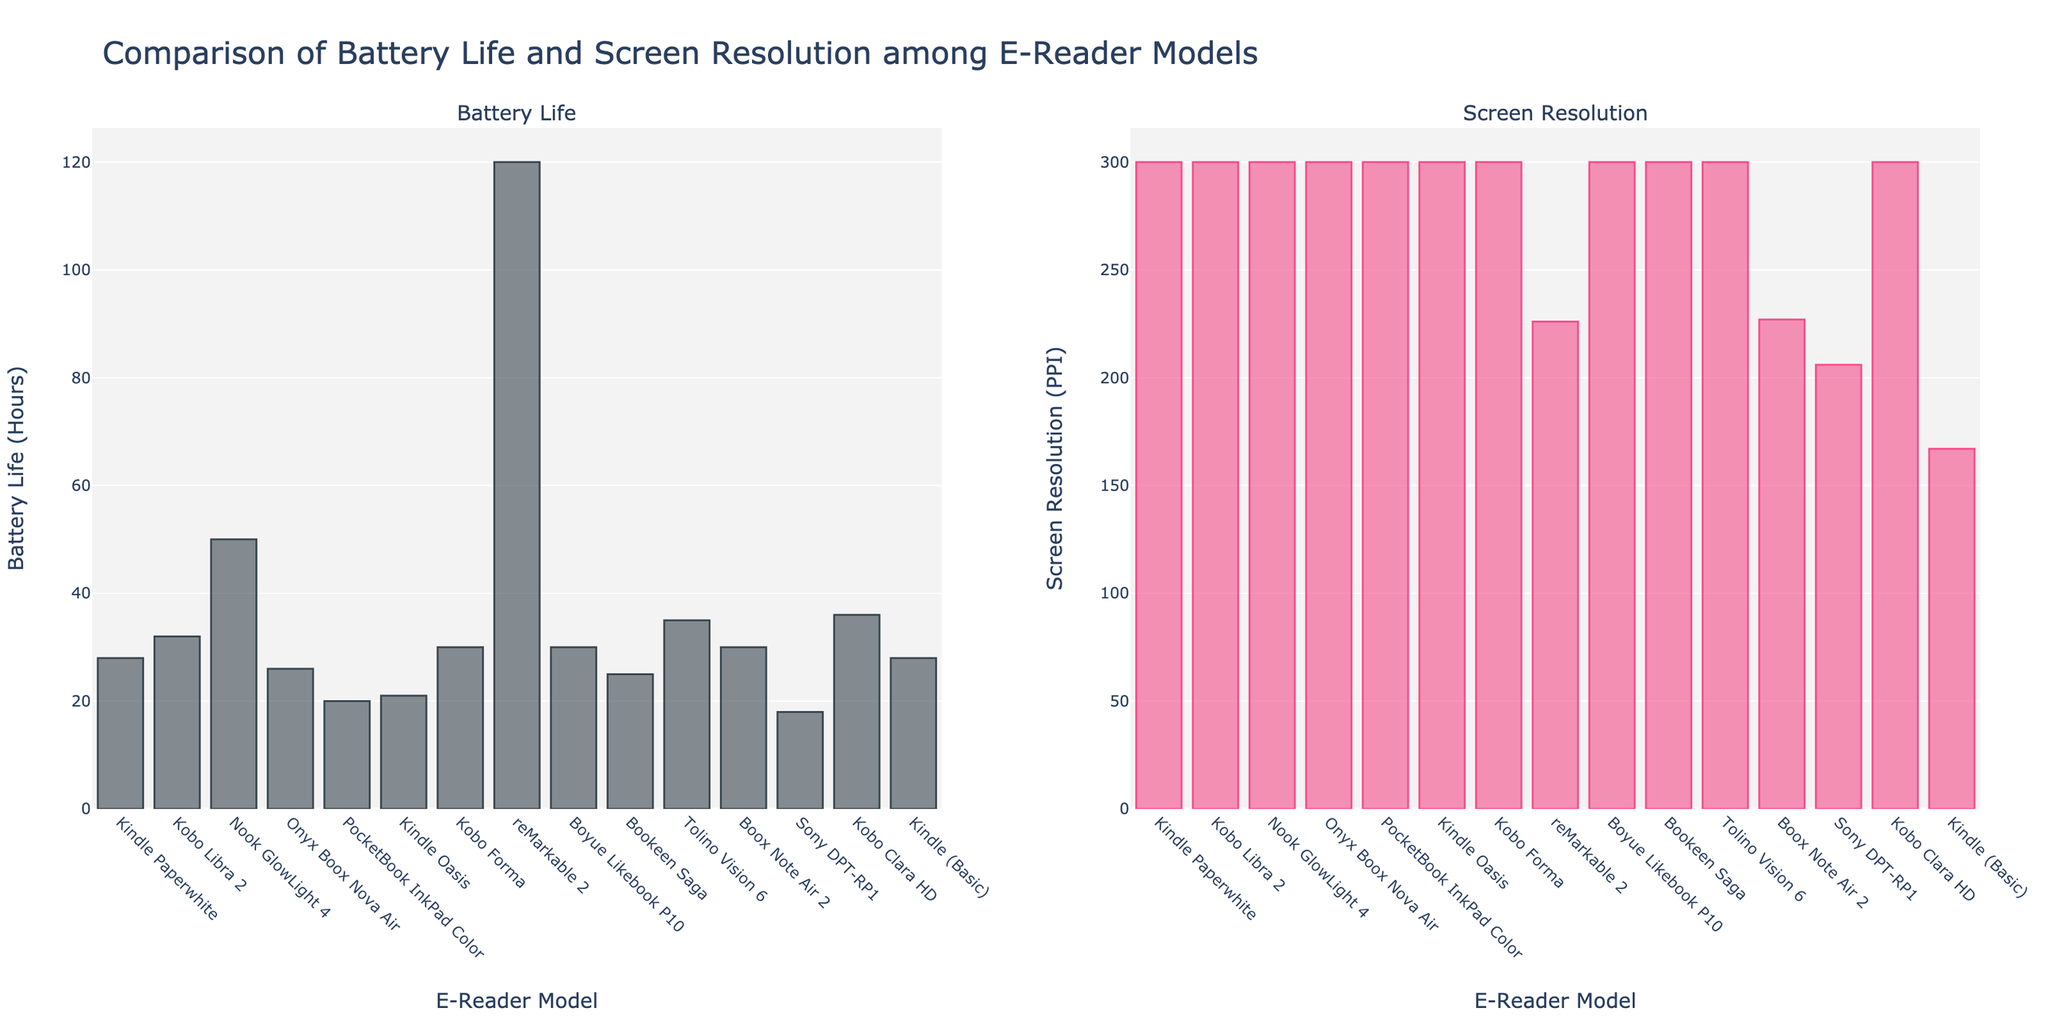Which e-reader model has the longest battery life? To find the e-reader with the longest battery life, look at the "Battery Life" bar chart. Identify the bar that reaches the highest point. The "reMarkable 2" has the highest bar, indicating it has the longest battery life.
Answer: reMarkable 2 Which two models have a battery life closest to 30 hours? To determine the e-readers with battery life closest to 30 hours, inspect the "Battery Life" bars and find those that are near the 30-hour mark. The "Kobo Forma" and "Boyue Likebook P10" both have bars at 30 hours.
Answer: Kobo Forma, Boyue Likebook P10 What is the difference in battery life between the "Nook GlowLight 4" and the "Sony DPT-RP1"? Find the "Battery Life" bars for these two models. The "Nook GlowLight 4" has 50 hours of battery life while the "Sony DPT-RP1" has 18 hours. Calculate the difference: 50 - 18.
Answer: 32 hours Which e-reader model has the lowest screen resolution? Examine the "Screen Resolution" bar chart and identify the lowest bar. The "Kindle (Basic)" has the lowest bar at a resolution of 167 PPI.
Answer: Kindle (Basic) How many e-reader models have a screen resolution of 300 PPI? Count the number of bars in the "Screen Resolution" chart that reach the 300 PPI mark. There are 12 models with this resolution.
Answer: 12 Which model has a longer battery life, the "Kindle Paperwhite" or the "Kobo Libra 2"? Compare the heights of their "Battery Life" bars. The "Kobo Libra 2" has a higher bar at 32 hours, compared to the "Kindle Paperwhite" at 28 hours.
Answer: Kobo Libra 2 What is the average battery life of the e-reader models in this comparison? Sum the battery life of all models and divide by the number of models. Adding battery lives: 28 + 32 + 50 + 26 + 20 + 21 + 30 + 120 + 30 + 25 + 35 + 30 + 18 + 36 + 28 = 509. Divide by the number of models (15). 509 / 15 = 33.93.
Answer: 33.93 hours How does the battery life of the "Tolino Vision 6" compare to the "PocketBook InkPad Color"? Check the heights of their "Battery Life" bars. The "Tolino Vision 6" has a bar at 35 hours, while the "PocketBook InkPad Color" is at 20 hours. The "Tolino Vision 6" has a longer battery life.
Answer: Tolino Vision 6 Which e-reader model has a screen resolution below 300 PPI but above 200 PPI? Identify bars in the "Screen Resolution" chart between 200 and 300 PPI. The "reMarkable 2" and "Boox Note Air 2" have screen resolutions of 226 and 227 PPI, respectively.
Answer: reMarkable 2, Boox Note Air 2 What is the combined battery life of the "Kindle Oasis" and "Bookeen Saga"? Find their "Battery Life" bars; "Kindle Oasis" has 21 hours and "Bookeen Saga" has 25 hours. Summing them: 21 + 25.
Answer: 46 hours 